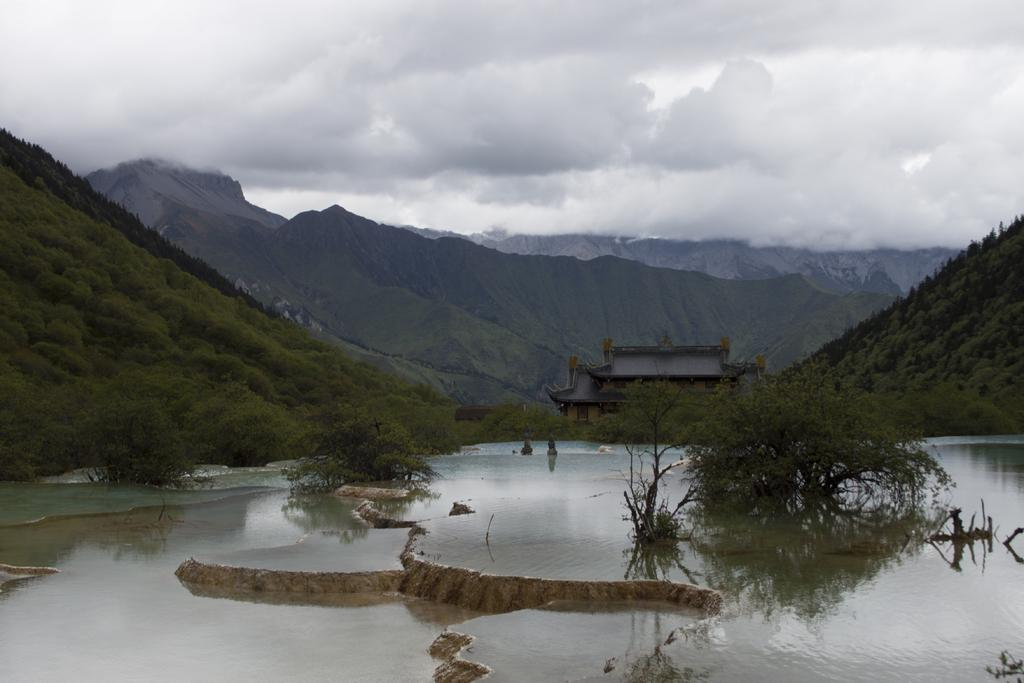What type of natural landform can be seen in the image? There are mountains in the image. What type of vegetation is present in the image? There are trees in the image. What body of water is visible in the image? There is water visible in the image. What type of structure can be seen in the image? There is a house in the image. What part of the sky is visible in the image? The sky is visible in the image. What atmospheric feature can be seen in the sky? There are clouds in the image. Can you tell me how many ears are visible on the mountains in the image? There are no ears present in the image; it features mountains, trees, water, a house, the sky, and clouds. What type of street can be seen in the image? There is no street present in the image. 